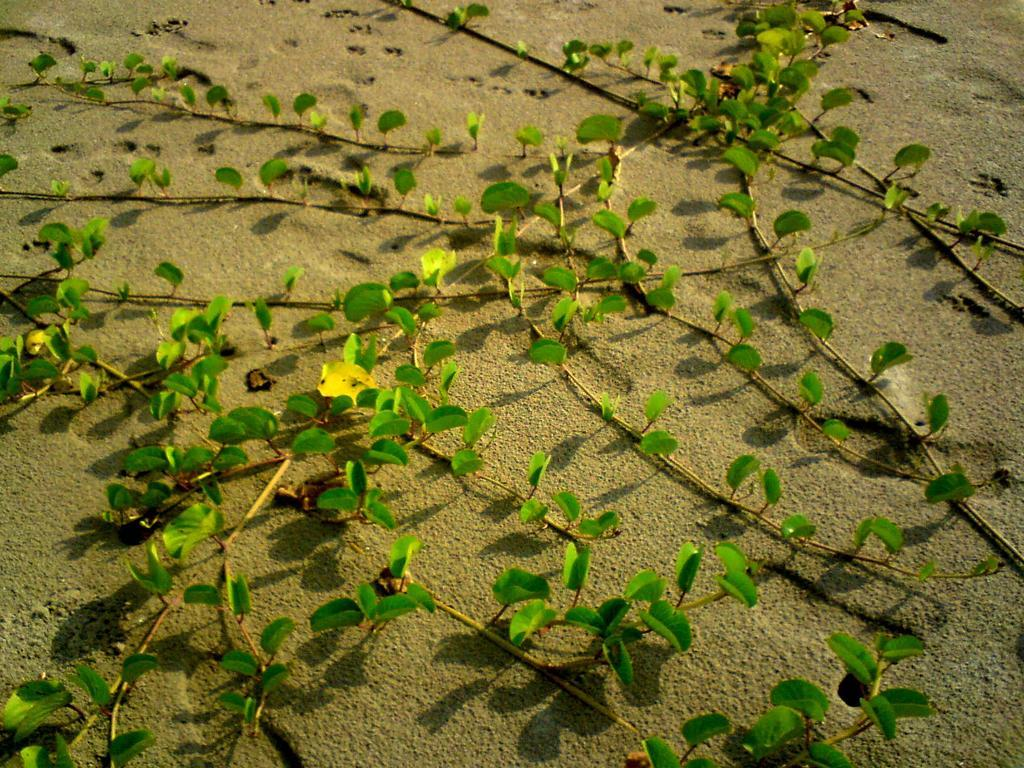What type of plants can be seen on the sand? There are plants on the sand. What else can be observed on the sand? There are footprints on the sand. What type of cow is wearing a hat in the image? There is no cow or hat present in the image. 